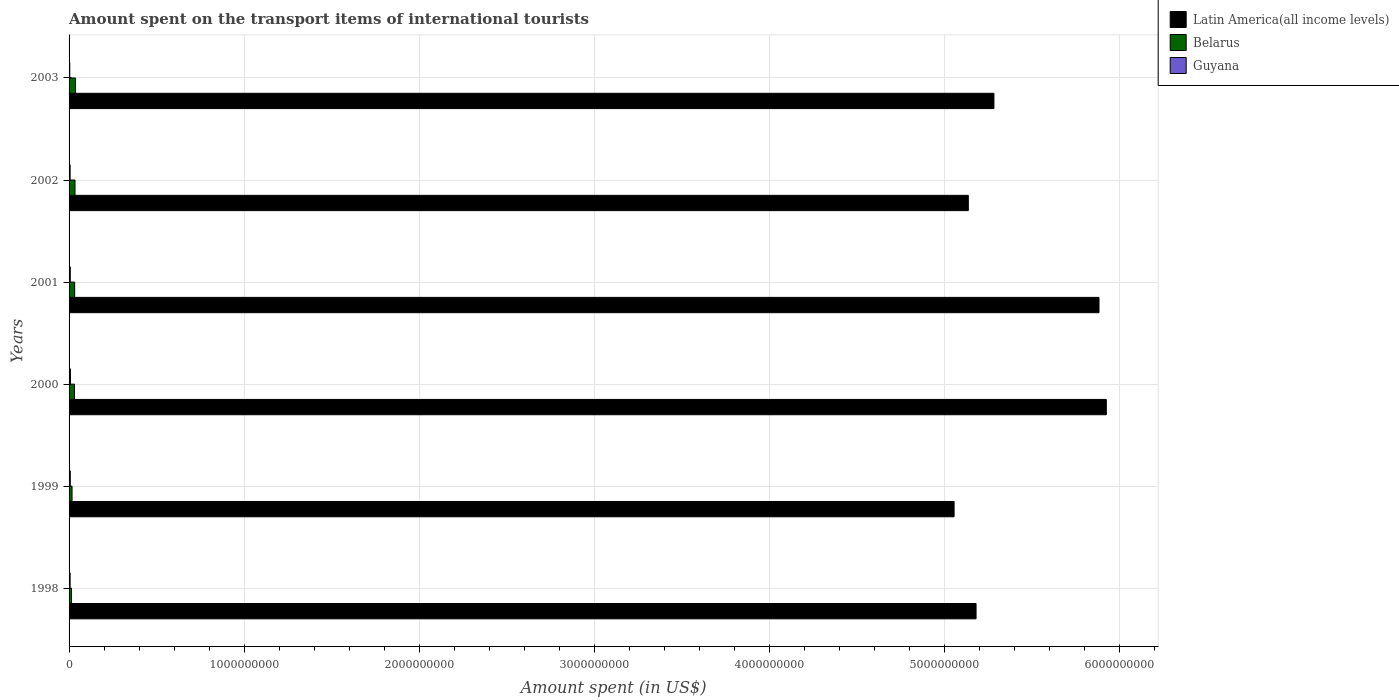How many different coloured bars are there?
Your answer should be very brief. 3. How many groups of bars are there?
Provide a short and direct response. 6. Are the number of bars on each tick of the Y-axis equal?
Provide a succinct answer. Yes. What is the label of the 1st group of bars from the top?
Ensure brevity in your answer.  2003. In how many cases, is the number of bars for a given year not equal to the number of legend labels?
Make the answer very short. 0. What is the amount spent on the transport items of international tourists in Latin America(all income levels) in 2002?
Ensure brevity in your answer.  5.14e+09. Across all years, what is the maximum amount spent on the transport items of international tourists in Belarus?
Provide a succinct answer. 3.70e+07. Across all years, what is the minimum amount spent on the transport items of international tourists in Belarus?
Your answer should be compact. 1.40e+07. What is the total amount spent on the transport items of international tourists in Belarus in the graph?
Provide a short and direct response. 1.65e+08. What is the difference between the amount spent on the transport items of international tourists in Belarus in 2002 and that in 2003?
Offer a terse response. -3.00e+06. What is the difference between the amount spent on the transport items of international tourists in Guyana in 2001 and the amount spent on the transport items of international tourists in Belarus in 1999?
Your answer should be compact. -1.00e+07. What is the average amount spent on the transport items of international tourists in Belarus per year?
Your answer should be very brief. 2.75e+07. In the year 2001, what is the difference between the amount spent on the transport items of international tourists in Guyana and amount spent on the transport items of international tourists in Belarus?
Offer a terse response. -2.50e+07. In how many years, is the amount spent on the transport items of international tourists in Latin America(all income levels) greater than 5800000000 US$?
Give a very brief answer. 2. What is the ratio of the amount spent on the transport items of international tourists in Belarus in 1999 to that in 2000?
Your answer should be very brief. 0.55. Is the difference between the amount spent on the transport items of international tourists in Guyana in 1998 and 2001 greater than the difference between the amount spent on the transport items of international tourists in Belarus in 1998 and 2001?
Make the answer very short. Yes. What is the difference between the highest and the lowest amount spent on the transport items of international tourists in Belarus?
Ensure brevity in your answer.  2.30e+07. Is the sum of the amount spent on the transport items of international tourists in Latin America(all income levels) in 2000 and 2001 greater than the maximum amount spent on the transport items of international tourists in Guyana across all years?
Provide a succinct answer. Yes. What does the 1st bar from the top in 2002 represents?
Provide a short and direct response. Guyana. What does the 3rd bar from the bottom in 2001 represents?
Provide a short and direct response. Guyana. What is the difference between two consecutive major ticks on the X-axis?
Give a very brief answer. 1.00e+09. Does the graph contain any zero values?
Offer a very short reply. No. Does the graph contain grids?
Make the answer very short. Yes. Where does the legend appear in the graph?
Your answer should be compact. Top right. How many legend labels are there?
Make the answer very short. 3. How are the legend labels stacked?
Your answer should be compact. Vertical. What is the title of the graph?
Provide a succinct answer. Amount spent on the transport items of international tourists. What is the label or title of the X-axis?
Offer a very short reply. Amount spent (in US$). What is the Amount spent (in US$) in Latin America(all income levels) in 1998?
Your answer should be compact. 5.18e+09. What is the Amount spent (in US$) in Belarus in 1998?
Your answer should be compact. 1.40e+07. What is the Amount spent (in US$) in Guyana in 1998?
Your response must be concise. 6.00e+06. What is the Amount spent (in US$) in Latin America(all income levels) in 1999?
Your answer should be compact. 5.06e+09. What is the Amount spent (in US$) in Belarus in 1999?
Ensure brevity in your answer.  1.70e+07. What is the Amount spent (in US$) of Latin America(all income levels) in 2000?
Keep it short and to the point. 5.93e+09. What is the Amount spent (in US$) in Belarus in 2000?
Give a very brief answer. 3.10e+07. What is the Amount spent (in US$) of Guyana in 2000?
Your answer should be very brief. 8.00e+06. What is the Amount spent (in US$) of Latin America(all income levels) in 2001?
Give a very brief answer. 5.89e+09. What is the Amount spent (in US$) in Belarus in 2001?
Offer a terse response. 3.20e+07. What is the Amount spent (in US$) in Latin America(all income levels) in 2002?
Give a very brief answer. 5.14e+09. What is the Amount spent (in US$) in Belarus in 2002?
Your answer should be compact. 3.40e+07. What is the Amount spent (in US$) of Guyana in 2002?
Make the answer very short. 6.00e+06. What is the Amount spent (in US$) of Latin America(all income levels) in 2003?
Your answer should be very brief. 5.29e+09. What is the Amount spent (in US$) of Belarus in 2003?
Ensure brevity in your answer.  3.70e+07. Across all years, what is the maximum Amount spent (in US$) of Latin America(all income levels)?
Keep it short and to the point. 5.93e+09. Across all years, what is the maximum Amount spent (in US$) in Belarus?
Provide a short and direct response. 3.70e+07. Across all years, what is the minimum Amount spent (in US$) of Latin America(all income levels)?
Keep it short and to the point. 5.06e+09. Across all years, what is the minimum Amount spent (in US$) in Belarus?
Keep it short and to the point. 1.40e+07. What is the total Amount spent (in US$) of Latin America(all income levels) in the graph?
Provide a succinct answer. 3.25e+1. What is the total Amount spent (in US$) in Belarus in the graph?
Your response must be concise. 1.65e+08. What is the total Amount spent (in US$) of Guyana in the graph?
Your response must be concise. 3.80e+07. What is the difference between the Amount spent (in US$) of Latin America(all income levels) in 1998 and that in 1999?
Your answer should be compact. 1.26e+08. What is the difference between the Amount spent (in US$) in Latin America(all income levels) in 1998 and that in 2000?
Provide a short and direct response. -7.44e+08. What is the difference between the Amount spent (in US$) of Belarus in 1998 and that in 2000?
Offer a very short reply. -1.70e+07. What is the difference between the Amount spent (in US$) of Latin America(all income levels) in 1998 and that in 2001?
Your answer should be very brief. -7.03e+08. What is the difference between the Amount spent (in US$) of Belarus in 1998 and that in 2001?
Offer a terse response. -1.80e+07. What is the difference between the Amount spent (in US$) of Guyana in 1998 and that in 2001?
Your response must be concise. -1.00e+06. What is the difference between the Amount spent (in US$) in Latin America(all income levels) in 1998 and that in 2002?
Provide a short and direct response. 4.43e+07. What is the difference between the Amount spent (in US$) in Belarus in 1998 and that in 2002?
Your response must be concise. -2.00e+07. What is the difference between the Amount spent (in US$) in Guyana in 1998 and that in 2002?
Provide a succinct answer. 0. What is the difference between the Amount spent (in US$) of Latin America(all income levels) in 1998 and that in 2003?
Ensure brevity in your answer.  -1.02e+08. What is the difference between the Amount spent (in US$) of Belarus in 1998 and that in 2003?
Ensure brevity in your answer.  -2.30e+07. What is the difference between the Amount spent (in US$) in Latin America(all income levels) in 1999 and that in 2000?
Provide a succinct answer. -8.70e+08. What is the difference between the Amount spent (in US$) in Belarus in 1999 and that in 2000?
Your answer should be very brief. -1.40e+07. What is the difference between the Amount spent (in US$) in Guyana in 1999 and that in 2000?
Your response must be concise. -1.00e+06. What is the difference between the Amount spent (in US$) of Latin America(all income levels) in 1999 and that in 2001?
Provide a short and direct response. -8.28e+08. What is the difference between the Amount spent (in US$) of Belarus in 1999 and that in 2001?
Keep it short and to the point. -1.50e+07. What is the difference between the Amount spent (in US$) in Latin America(all income levels) in 1999 and that in 2002?
Provide a succinct answer. -8.12e+07. What is the difference between the Amount spent (in US$) of Belarus in 1999 and that in 2002?
Make the answer very short. -1.70e+07. What is the difference between the Amount spent (in US$) of Guyana in 1999 and that in 2002?
Offer a very short reply. 1.00e+06. What is the difference between the Amount spent (in US$) of Latin America(all income levels) in 1999 and that in 2003?
Offer a very short reply. -2.28e+08. What is the difference between the Amount spent (in US$) of Belarus in 1999 and that in 2003?
Give a very brief answer. -2.00e+07. What is the difference between the Amount spent (in US$) of Guyana in 1999 and that in 2003?
Provide a short and direct response. 3.00e+06. What is the difference between the Amount spent (in US$) in Latin America(all income levels) in 2000 and that in 2001?
Your answer should be very brief. 4.18e+07. What is the difference between the Amount spent (in US$) of Belarus in 2000 and that in 2001?
Offer a very short reply. -1.00e+06. What is the difference between the Amount spent (in US$) of Guyana in 2000 and that in 2001?
Your answer should be very brief. 1.00e+06. What is the difference between the Amount spent (in US$) of Latin America(all income levels) in 2000 and that in 2002?
Provide a short and direct response. 7.89e+08. What is the difference between the Amount spent (in US$) of Belarus in 2000 and that in 2002?
Your answer should be very brief. -3.00e+06. What is the difference between the Amount spent (in US$) of Latin America(all income levels) in 2000 and that in 2003?
Your response must be concise. 6.42e+08. What is the difference between the Amount spent (in US$) in Belarus in 2000 and that in 2003?
Provide a short and direct response. -6.00e+06. What is the difference between the Amount spent (in US$) of Guyana in 2000 and that in 2003?
Keep it short and to the point. 4.00e+06. What is the difference between the Amount spent (in US$) of Latin America(all income levels) in 2001 and that in 2002?
Your response must be concise. 7.47e+08. What is the difference between the Amount spent (in US$) in Belarus in 2001 and that in 2002?
Ensure brevity in your answer.  -2.00e+06. What is the difference between the Amount spent (in US$) in Guyana in 2001 and that in 2002?
Your response must be concise. 1.00e+06. What is the difference between the Amount spent (in US$) in Latin America(all income levels) in 2001 and that in 2003?
Make the answer very short. 6.00e+08. What is the difference between the Amount spent (in US$) in Belarus in 2001 and that in 2003?
Provide a succinct answer. -5.00e+06. What is the difference between the Amount spent (in US$) of Guyana in 2001 and that in 2003?
Your answer should be compact. 3.00e+06. What is the difference between the Amount spent (in US$) of Latin America(all income levels) in 2002 and that in 2003?
Provide a short and direct response. -1.46e+08. What is the difference between the Amount spent (in US$) in Belarus in 2002 and that in 2003?
Your response must be concise. -3.00e+06. What is the difference between the Amount spent (in US$) of Latin America(all income levels) in 1998 and the Amount spent (in US$) of Belarus in 1999?
Your answer should be very brief. 5.17e+09. What is the difference between the Amount spent (in US$) in Latin America(all income levels) in 1998 and the Amount spent (in US$) in Guyana in 1999?
Make the answer very short. 5.18e+09. What is the difference between the Amount spent (in US$) of Belarus in 1998 and the Amount spent (in US$) of Guyana in 1999?
Make the answer very short. 7.00e+06. What is the difference between the Amount spent (in US$) in Latin America(all income levels) in 1998 and the Amount spent (in US$) in Belarus in 2000?
Your answer should be very brief. 5.15e+09. What is the difference between the Amount spent (in US$) in Latin America(all income levels) in 1998 and the Amount spent (in US$) in Guyana in 2000?
Provide a succinct answer. 5.17e+09. What is the difference between the Amount spent (in US$) of Belarus in 1998 and the Amount spent (in US$) of Guyana in 2000?
Give a very brief answer. 6.00e+06. What is the difference between the Amount spent (in US$) in Latin America(all income levels) in 1998 and the Amount spent (in US$) in Belarus in 2001?
Make the answer very short. 5.15e+09. What is the difference between the Amount spent (in US$) of Latin America(all income levels) in 1998 and the Amount spent (in US$) of Guyana in 2001?
Ensure brevity in your answer.  5.18e+09. What is the difference between the Amount spent (in US$) of Belarus in 1998 and the Amount spent (in US$) of Guyana in 2001?
Provide a short and direct response. 7.00e+06. What is the difference between the Amount spent (in US$) of Latin America(all income levels) in 1998 and the Amount spent (in US$) of Belarus in 2002?
Provide a short and direct response. 5.15e+09. What is the difference between the Amount spent (in US$) in Latin America(all income levels) in 1998 and the Amount spent (in US$) in Guyana in 2002?
Your response must be concise. 5.18e+09. What is the difference between the Amount spent (in US$) in Belarus in 1998 and the Amount spent (in US$) in Guyana in 2002?
Provide a succinct answer. 8.00e+06. What is the difference between the Amount spent (in US$) of Latin America(all income levels) in 1998 and the Amount spent (in US$) of Belarus in 2003?
Offer a very short reply. 5.15e+09. What is the difference between the Amount spent (in US$) of Latin America(all income levels) in 1998 and the Amount spent (in US$) of Guyana in 2003?
Your response must be concise. 5.18e+09. What is the difference between the Amount spent (in US$) in Latin America(all income levels) in 1999 and the Amount spent (in US$) in Belarus in 2000?
Give a very brief answer. 5.03e+09. What is the difference between the Amount spent (in US$) of Latin America(all income levels) in 1999 and the Amount spent (in US$) of Guyana in 2000?
Offer a very short reply. 5.05e+09. What is the difference between the Amount spent (in US$) of Belarus in 1999 and the Amount spent (in US$) of Guyana in 2000?
Your answer should be compact. 9.00e+06. What is the difference between the Amount spent (in US$) in Latin America(all income levels) in 1999 and the Amount spent (in US$) in Belarus in 2001?
Your response must be concise. 5.03e+09. What is the difference between the Amount spent (in US$) in Latin America(all income levels) in 1999 and the Amount spent (in US$) in Guyana in 2001?
Your answer should be very brief. 5.05e+09. What is the difference between the Amount spent (in US$) in Latin America(all income levels) in 1999 and the Amount spent (in US$) in Belarus in 2002?
Offer a terse response. 5.02e+09. What is the difference between the Amount spent (in US$) in Latin America(all income levels) in 1999 and the Amount spent (in US$) in Guyana in 2002?
Make the answer very short. 5.05e+09. What is the difference between the Amount spent (in US$) of Belarus in 1999 and the Amount spent (in US$) of Guyana in 2002?
Your answer should be compact. 1.10e+07. What is the difference between the Amount spent (in US$) of Latin America(all income levels) in 1999 and the Amount spent (in US$) of Belarus in 2003?
Offer a terse response. 5.02e+09. What is the difference between the Amount spent (in US$) in Latin America(all income levels) in 1999 and the Amount spent (in US$) in Guyana in 2003?
Your response must be concise. 5.05e+09. What is the difference between the Amount spent (in US$) in Belarus in 1999 and the Amount spent (in US$) in Guyana in 2003?
Offer a terse response. 1.30e+07. What is the difference between the Amount spent (in US$) of Latin America(all income levels) in 2000 and the Amount spent (in US$) of Belarus in 2001?
Ensure brevity in your answer.  5.90e+09. What is the difference between the Amount spent (in US$) in Latin America(all income levels) in 2000 and the Amount spent (in US$) in Guyana in 2001?
Your response must be concise. 5.92e+09. What is the difference between the Amount spent (in US$) in Belarus in 2000 and the Amount spent (in US$) in Guyana in 2001?
Give a very brief answer. 2.40e+07. What is the difference between the Amount spent (in US$) of Latin America(all income levels) in 2000 and the Amount spent (in US$) of Belarus in 2002?
Give a very brief answer. 5.89e+09. What is the difference between the Amount spent (in US$) in Latin America(all income levels) in 2000 and the Amount spent (in US$) in Guyana in 2002?
Offer a terse response. 5.92e+09. What is the difference between the Amount spent (in US$) in Belarus in 2000 and the Amount spent (in US$) in Guyana in 2002?
Provide a succinct answer. 2.50e+07. What is the difference between the Amount spent (in US$) in Latin America(all income levels) in 2000 and the Amount spent (in US$) in Belarus in 2003?
Offer a terse response. 5.89e+09. What is the difference between the Amount spent (in US$) of Latin America(all income levels) in 2000 and the Amount spent (in US$) of Guyana in 2003?
Ensure brevity in your answer.  5.92e+09. What is the difference between the Amount spent (in US$) of Belarus in 2000 and the Amount spent (in US$) of Guyana in 2003?
Provide a short and direct response. 2.70e+07. What is the difference between the Amount spent (in US$) of Latin America(all income levels) in 2001 and the Amount spent (in US$) of Belarus in 2002?
Your answer should be compact. 5.85e+09. What is the difference between the Amount spent (in US$) of Latin America(all income levels) in 2001 and the Amount spent (in US$) of Guyana in 2002?
Make the answer very short. 5.88e+09. What is the difference between the Amount spent (in US$) of Belarus in 2001 and the Amount spent (in US$) of Guyana in 2002?
Make the answer very short. 2.60e+07. What is the difference between the Amount spent (in US$) of Latin America(all income levels) in 2001 and the Amount spent (in US$) of Belarus in 2003?
Keep it short and to the point. 5.85e+09. What is the difference between the Amount spent (in US$) of Latin America(all income levels) in 2001 and the Amount spent (in US$) of Guyana in 2003?
Your answer should be compact. 5.88e+09. What is the difference between the Amount spent (in US$) of Belarus in 2001 and the Amount spent (in US$) of Guyana in 2003?
Give a very brief answer. 2.80e+07. What is the difference between the Amount spent (in US$) of Latin America(all income levels) in 2002 and the Amount spent (in US$) of Belarus in 2003?
Your answer should be compact. 5.10e+09. What is the difference between the Amount spent (in US$) of Latin America(all income levels) in 2002 and the Amount spent (in US$) of Guyana in 2003?
Provide a short and direct response. 5.13e+09. What is the difference between the Amount spent (in US$) of Belarus in 2002 and the Amount spent (in US$) of Guyana in 2003?
Your answer should be very brief. 3.00e+07. What is the average Amount spent (in US$) in Latin America(all income levels) per year?
Your answer should be very brief. 5.41e+09. What is the average Amount spent (in US$) of Belarus per year?
Provide a short and direct response. 2.75e+07. What is the average Amount spent (in US$) of Guyana per year?
Give a very brief answer. 6.33e+06. In the year 1998, what is the difference between the Amount spent (in US$) in Latin America(all income levels) and Amount spent (in US$) in Belarus?
Make the answer very short. 5.17e+09. In the year 1998, what is the difference between the Amount spent (in US$) in Latin America(all income levels) and Amount spent (in US$) in Guyana?
Offer a very short reply. 5.18e+09. In the year 1999, what is the difference between the Amount spent (in US$) of Latin America(all income levels) and Amount spent (in US$) of Belarus?
Offer a very short reply. 5.04e+09. In the year 1999, what is the difference between the Amount spent (in US$) of Latin America(all income levels) and Amount spent (in US$) of Guyana?
Provide a short and direct response. 5.05e+09. In the year 2000, what is the difference between the Amount spent (in US$) in Latin America(all income levels) and Amount spent (in US$) in Belarus?
Offer a very short reply. 5.90e+09. In the year 2000, what is the difference between the Amount spent (in US$) in Latin America(all income levels) and Amount spent (in US$) in Guyana?
Make the answer very short. 5.92e+09. In the year 2000, what is the difference between the Amount spent (in US$) of Belarus and Amount spent (in US$) of Guyana?
Keep it short and to the point. 2.30e+07. In the year 2001, what is the difference between the Amount spent (in US$) of Latin America(all income levels) and Amount spent (in US$) of Belarus?
Provide a succinct answer. 5.85e+09. In the year 2001, what is the difference between the Amount spent (in US$) of Latin America(all income levels) and Amount spent (in US$) of Guyana?
Make the answer very short. 5.88e+09. In the year 2001, what is the difference between the Amount spent (in US$) in Belarus and Amount spent (in US$) in Guyana?
Provide a succinct answer. 2.50e+07. In the year 2002, what is the difference between the Amount spent (in US$) of Latin America(all income levels) and Amount spent (in US$) of Belarus?
Your response must be concise. 5.10e+09. In the year 2002, what is the difference between the Amount spent (in US$) in Latin America(all income levels) and Amount spent (in US$) in Guyana?
Make the answer very short. 5.13e+09. In the year 2002, what is the difference between the Amount spent (in US$) of Belarus and Amount spent (in US$) of Guyana?
Give a very brief answer. 2.80e+07. In the year 2003, what is the difference between the Amount spent (in US$) of Latin America(all income levels) and Amount spent (in US$) of Belarus?
Provide a succinct answer. 5.25e+09. In the year 2003, what is the difference between the Amount spent (in US$) of Latin America(all income levels) and Amount spent (in US$) of Guyana?
Give a very brief answer. 5.28e+09. In the year 2003, what is the difference between the Amount spent (in US$) of Belarus and Amount spent (in US$) of Guyana?
Give a very brief answer. 3.30e+07. What is the ratio of the Amount spent (in US$) of Latin America(all income levels) in 1998 to that in 1999?
Make the answer very short. 1.02. What is the ratio of the Amount spent (in US$) in Belarus in 1998 to that in 1999?
Your answer should be compact. 0.82. What is the ratio of the Amount spent (in US$) of Guyana in 1998 to that in 1999?
Your response must be concise. 0.86. What is the ratio of the Amount spent (in US$) in Latin America(all income levels) in 1998 to that in 2000?
Provide a short and direct response. 0.87. What is the ratio of the Amount spent (in US$) in Belarus in 1998 to that in 2000?
Make the answer very short. 0.45. What is the ratio of the Amount spent (in US$) in Guyana in 1998 to that in 2000?
Offer a very short reply. 0.75. What is the ratio of the Amount spent (in US$) in Latin America(all income levels) in 1998 to that in 2001?
Your answer should be compact. 0.88. What is the ratio of the Amount spent (in US$) in Belarus in 1998 to that in 2001?
Ensure brevity in your answer.  0.44. What is the ratio of the Amount spent (in US$) of Latin America(all income levels) in 1998 to that in 2002?
Ensure brevity in your answer.  1.01. What is the ratio of the Amount spent (in US$) in Belarus in 1998 to that in 2002?
Give a very brief answer. 0.41. What is the ratio of the Amount spent (in US$) in Guyana in 1998 to that in 2002?
Offer a very short reply. 1. What is the ratio of the Amount spent (in US$) in Latin America(all income levels) in 1998 to that in 2003?
Provide a short and direct response. 0.98. What is the ratio of the Amount spent (in US$) in Belarus in 1998 to that in 2003?
Ensure brevity in your answer.  0.38. What is the ratio of the Amount spent (in US$) of Latin America(all income levels) in 1999 to that in 2000?
Your answer should be compact. 0.85. What is the ratio of the Amount spent (in US$) in Belarus in 1999 to that in 2000?
Keep it short and to the point. 0.55. What is the ratio of the Amount spent (in US$) of Latin America(all income levels) in 1999 to that in 2001?
Ensure brevity in your answer.  0.86. What is the ratio of the Amount spent (in US$) of Belarus in 1999 to that in 2001?
Provide a succinct answer. 0.53. What is the ratio of the Amount spent (in US$) in Latin America(all income levels) in 1999 to that in 2002?
Offer a very short reply. 0.98. What is the ratio of the Amount spent (in US$) in Guyana in 1999 to that in 2002?
Your response must be concise. 1.17. What is the ratio of the Amount spent (in US$) in Latin America(all income levels) in 1999 to that in 2003?
Your response must be concise. 0.96. What is the ratio of the Amount spent (in US$) in Belarus in 1999 to that in 2003?
Provide a succinct answer. 0.46. What is the ratio of the Amount spent (in US$) of Latin America(all income levels) in 2000 to that in 2001?
Offer a very short reply. 1.01. What is the ratio of the Amount spent (in US$) in Belarus in 2000 to that in 2001?
Your answer should be very brief. 0.97. What is the ratio of the Amount spent (in US$) of Guyana in 2000 to that in 2001?
Make the answer very short. 1.14. What is the ratio of the Amount spent (in US$) in Latin America(all income levels) in 2000 to that in 2002?
Offer a very short reply. 1.15. What is the ratio of the Amount spent (in US$) of Belarus in 2000 to that in 2002?
Provide a short and direct response. 0.91. What is the ratio of the Amount spent (in US$) in Latin America(all income levels) in 2000 to that in 2003?
Ensure brevity in your answer.  1.12. What is the ratio of the Amount spent (in US$) in Belarus in 2000 to that in 2003?
Give a very brief answer. 0.84. What is the ratio of the Amount spent (in US$) of Guyana in 2000 to that in 2003?
Keep it short and to the point. 2. What is the ratio of the Amount spent (in US$) of Latin America(all income levels) in 2001 to that in 2002?
Give a very brief answer. 1.15. What is the ratio of the Amount spent (in US$) in Guyana in 2001 to that in 2002?
Offer a very short reply. 1.17. What is the ratio of the Amount spent (in US$) of Latin America(all income levels) in 2001 to that in 2003?
Make the answer very short. 1.11. What is the ratio of the Amount spent (in US$) in Belarus in 2001 to that in 2003?
Give a very brief answer. 0.86. What is the ratio of the Amount spent (in US$) in Guyana in 2001 to that in 2003?
Provide a succinct answer. 1.75. What is the ratio of the Amount spent (in US$) in Latin America(all income levels) in 2002 to that in 2003?
Provide a short and direct response. 0.97. What is the ratio of the Amount spent (in US$) of Belarus in 2002 to that in 2003?
Your response must be concise. 0.92. What is the difference between the highest and the second highest Amount spent (in US$) in Latin America(all income levels)?
Offer a very short reply. 4.18e+07. What is the difference between the highest and the second highest Amount spent (in US$) in Belarus?
Provide a succinct answer. 3.00e+06. What is the difference between the highest and the second highest Amount spent (in US$) in Guyana?
Provide a short and direct response. 1.00e+06. What is the difference between the highest and the lowest Amount spent (in US$) in Latin America(all income levels)?
Offer a terse response. 8.70e+08. What is the difference between the highest and the lowest Amount spent (in US$) of Belarus?
Your response must be concise. 2.30e+07. What is the difference between the highest and the lowest Amount spent (in US$) of Guyana?
Give a very brief answer. 4.00e+06. 